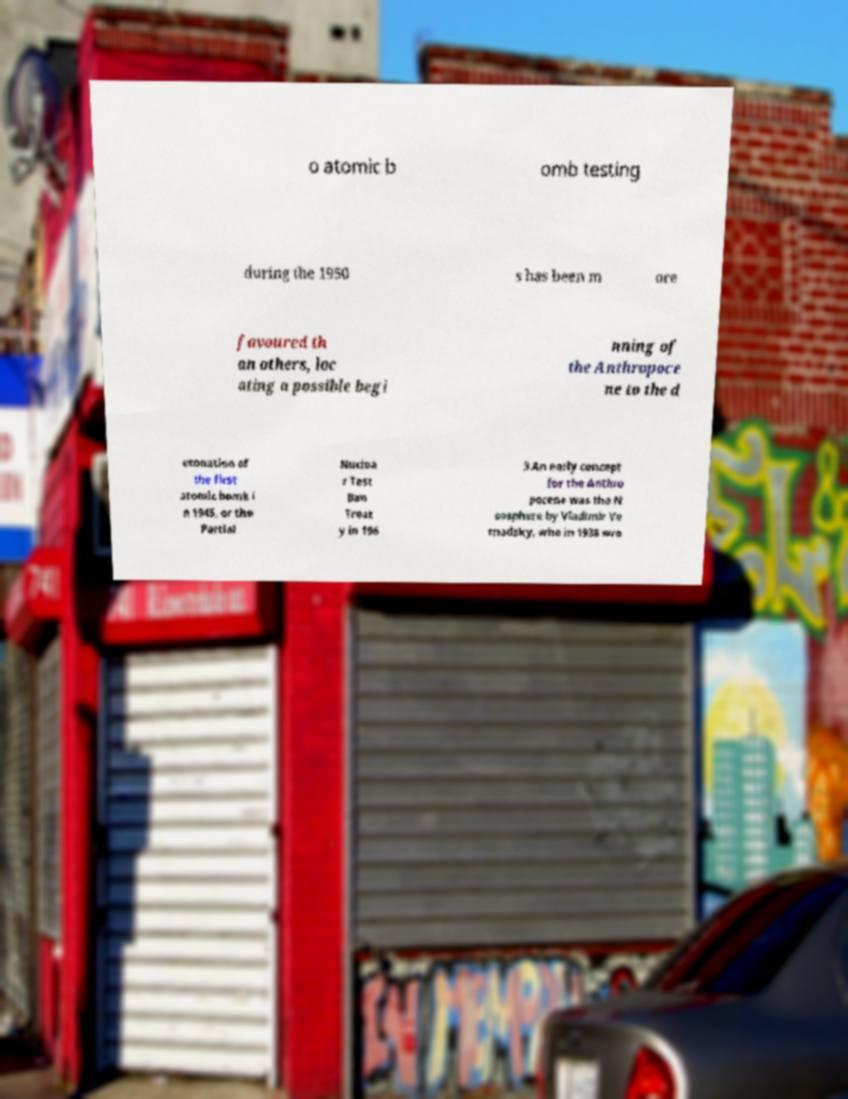For documentation purposes, I need the text within this image transcribed. Could you provide that? o atomic b omb testing during the 1950 s has been m ore favoured th an others, loc ating a possible begi nning of the Anthropoce ne to the d etonation of the first atomic bomb i n 1945, or the Partial Nuclea r Test Ban Treat y in 196 3.An early concept for the Anthro pocene was the N oosphere by Vladimir Ve rnadsky, who in 1938 wro 